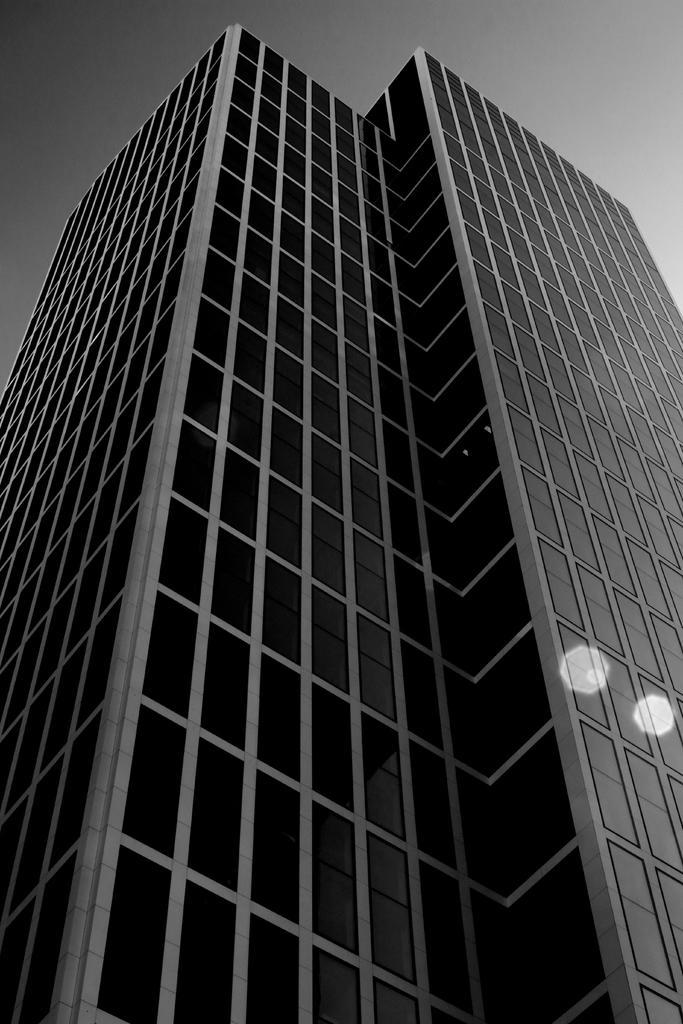How would you summarize this image in a sentence or two? This is a black and white image. This picture is taken from outside of the building, at the top, we can see a sky. 